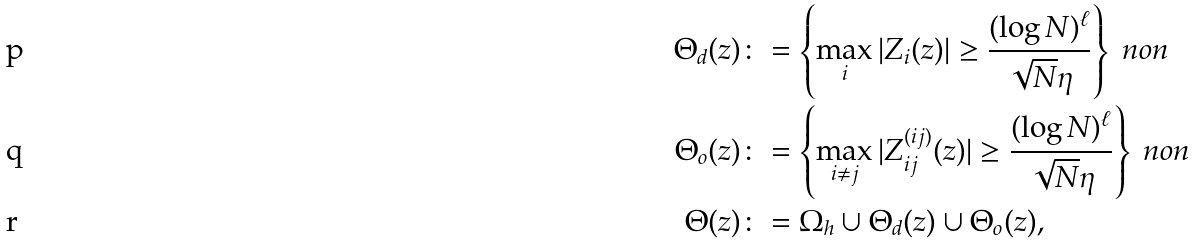Convert formula to latex. <formula><loc_0><loc_0><loc_500><loc_500>\Theta _ { d } ( z ) & \colon = \left \{ \max _ { i } | Z _ { i } ( z ) | \geq \frac { ( \log N ) ^ { \ell } } { \sqrt { N } \eta } \right \} \ n o n \\ \Theta _ { o } ( z ) & \colon = \left \{ \max _ { i \ne j } | Z _ { i j } ^ { ( i j ) } ( z ) | \geq \frac { ( \log N ) ^ { \ell } } { \sqrt { N } \eta } \right \} \ n o n \\ \Theta ( z ) & \colon = \Omega _ { h } \cup \Theta _ { d } ( z ) \cup \Theta _ { o } ( z ) ,</formula> 